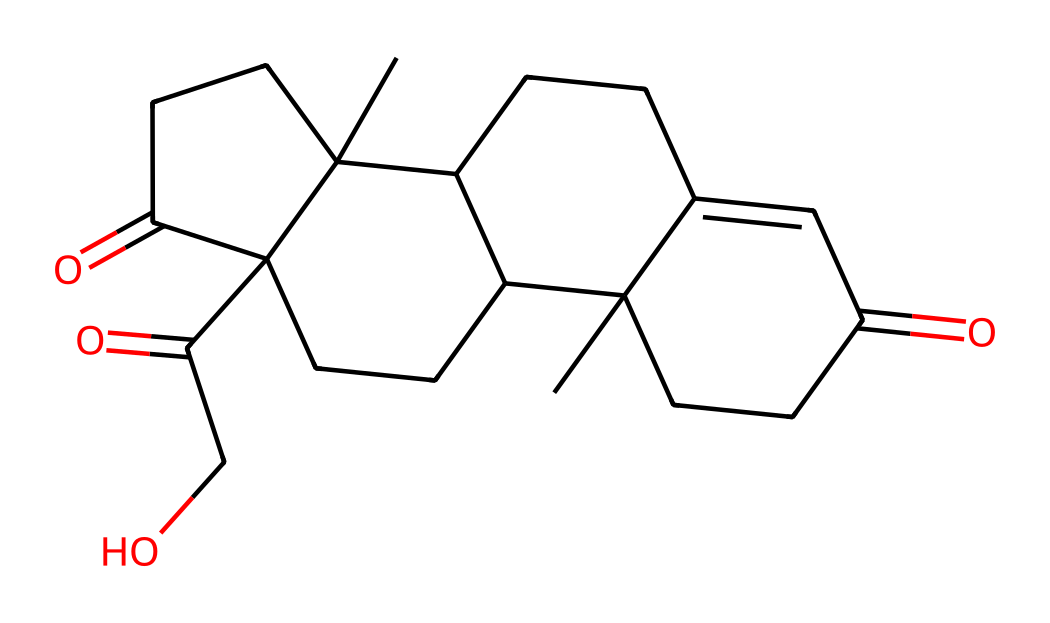What is the molecular formula of cortisol? By analyzing the structure, we can count the number of carbon (C), hydrogen (H), and oxygen (O) atoms. The structure appears to contain 21 carbon atoms, 30 hydrogen atoms, and 5 oxygen atoms, yielding the molecular formula C21H30O5.
Answer: C21H30O5 How many rings are present in the cortisol structure? In the SMILES representation, we can identify the numbers that indicate ring closures. There are multiple connections suggesting the presence of four fused rings in the cortisol structure. Hence, the total number of rings is four.
Answer: 4 What type of compound is cortisol classified as? Given the presence of multiple hydroxyl groups (-OH) and its characteristic steroid nucleus consistent with many hormones, cortisol can be classified as a steroid hormone.
Answer: steroid hormone Which functional groups are evident in the cortisol molecule? Inspecting the structure reveals several functional groups, primarily hydroxyl (-OH) groups and ketones (C=O), which are critical for its biological function. Therefore, the primary functional groups identified are hydroxyl and ketone.
Answer: hydroxyl and ketone How many double bonds are present in the cortisol structure? By tracing through the structure and identifying the double bonds, we can find one double bond in the valid structural representation of cortisol.
Answer: 1 What is the role of cortisol during intense sports activities? Cortisol acts as a stress hormone that helps regulate metabolism, inflammation, and immune responses, thereby facilitating the body’s adaptation to physical stress from intense sports.
Answer: stress hormone 